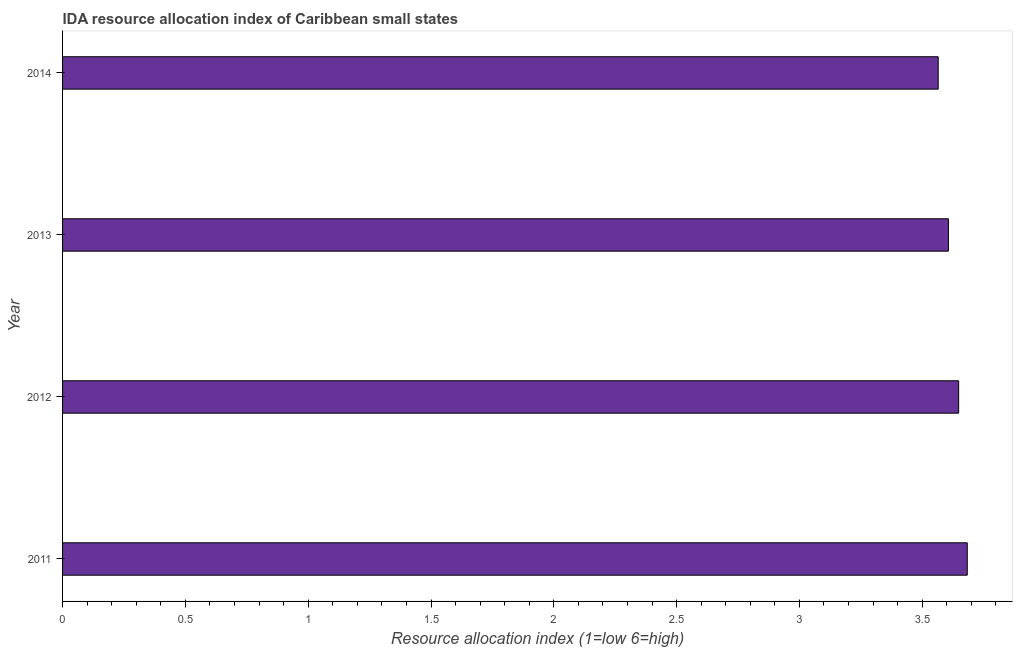What is the title of the graph?
Offer a terse response. IDA resource allocation index of Caribbean small states. What is the label or title of the X-axis?
Your answer should be compact. Resource allocation index (1=low 6=high). What is the label or title of the Y-axis?
Ensure brevity in your answer.  Year. What is the ida resource allocation index in 2011?
Your answer should be compact. 3.68. Across all years, what is the maximum ida resource allocation index?
Your answer should be very brief. 3.68. Across all years, what is the minimum ida resource allocation index?
Your answer should be very brief. 3.56. What is the sum of the ida resource allocation index?
Provide a succinct answer. 14.5. What is the difference between the ida resource allocation index in 2011 and 2013?
Make the answer very short. 0.08. What is the average ida resource allocation index per year?
Your response must be concise. 3.63. What is the median ida resource allocation index?
Your answer should be very brief. 3.63. Is the ida resource allocation index in 2011 less than that in 2012?
Give a very brief answer. No. What is the difference between the highest and the second highest ida resource allocation index?
Ensure brevity in your answer.  0.04. Is the sum of the ida resource allocation index in 2011 and 2014 greater than the maximum ida resource allocation index across all years?
Your response must be concise. Yes. What is the difference between the highest and the lowest ida resource allocation index?
Offer a terse response. 0.12. How many years are there in the graph?
Ensure brevity in your answer.  4. What is the Resource allocation index (1=low 6=high) in 2011?
Your response must be concise. 3.68. What is the Resource allocation index (1=low 6=high) of 2012?
Your answer should be compact. 3.65. What is the Resource allocation index (1=low 6=high) in 2013?
Offer a terse response. 3.61. What is the Resource allocation index (1=low 6=high) of 2014?
Your answer should be compact. 3.56. What is the difference between the Resource allocation index (1=low 6=high) in 2011 and 2012?
Make the answer very short. 0.04. What is the difference between the Resource allocation index (1=low 6=high) in 2011 and 2013?
Offer a very short reply. 0.08. What is the difference between the Resource allocation index (1=low 6=high) in 2011 and 2014?
Ensure brevity in your answer.  0.12. What is the difference between the Resource allocation index (1=low 6=high) in 2012 and 2013?
Make the answer very short. 0.04. What is the difference between the Resource allocation index (1=low 6=high) in 2012 and 2014?
Provide a succinct answer. 0.08. What is the difference between the Resource allocation index (1=low 6=high) in 2013 and 2014?
Make the answer very short. 0.04. What is the ratio of the Resource allocation index (1=low 6=high) in 2011 to that in 2014?
Provide a succinct answer. 1.03. What is the ratio of the Resource allocation index (1=low 6=high) in 2012 to that in 2013?
Give a very brief answer. 1.01. 